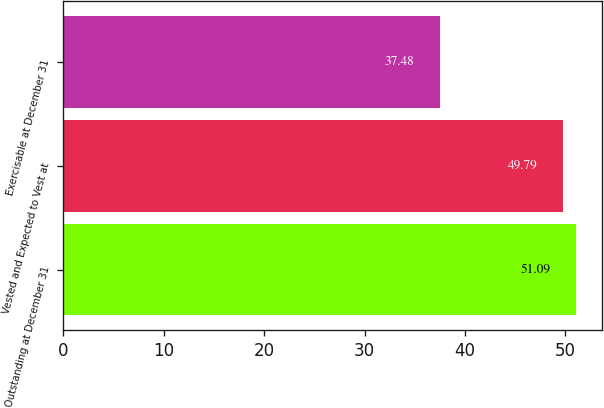<chart> <loc_0><loc_0><loc_500><loc_500><bar_chart><fcel>Outstanding at December 31<fcel>Vested and Expected to Vest at<fcel>Exercisable at December 31<nl><fcel>51.09<fcel>49.79<fcel>37.48<nl></chart> 